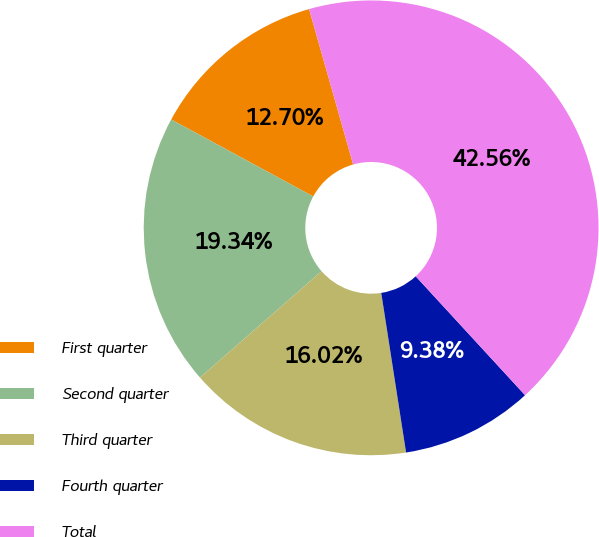Convert chart to OTSL. <chart><loc_0><loc_0><loc_500><loc_500><pie_chart><fcel>First quarter<fcel>Second quarter<fcel>Third quarter<fcel>Fourth quarter<fcel>Total<nl><fcel>12.7%<fcel>19.34%<fcel>16.02%<fcel>9.38%<fcel>42.56%<nl></chart> 